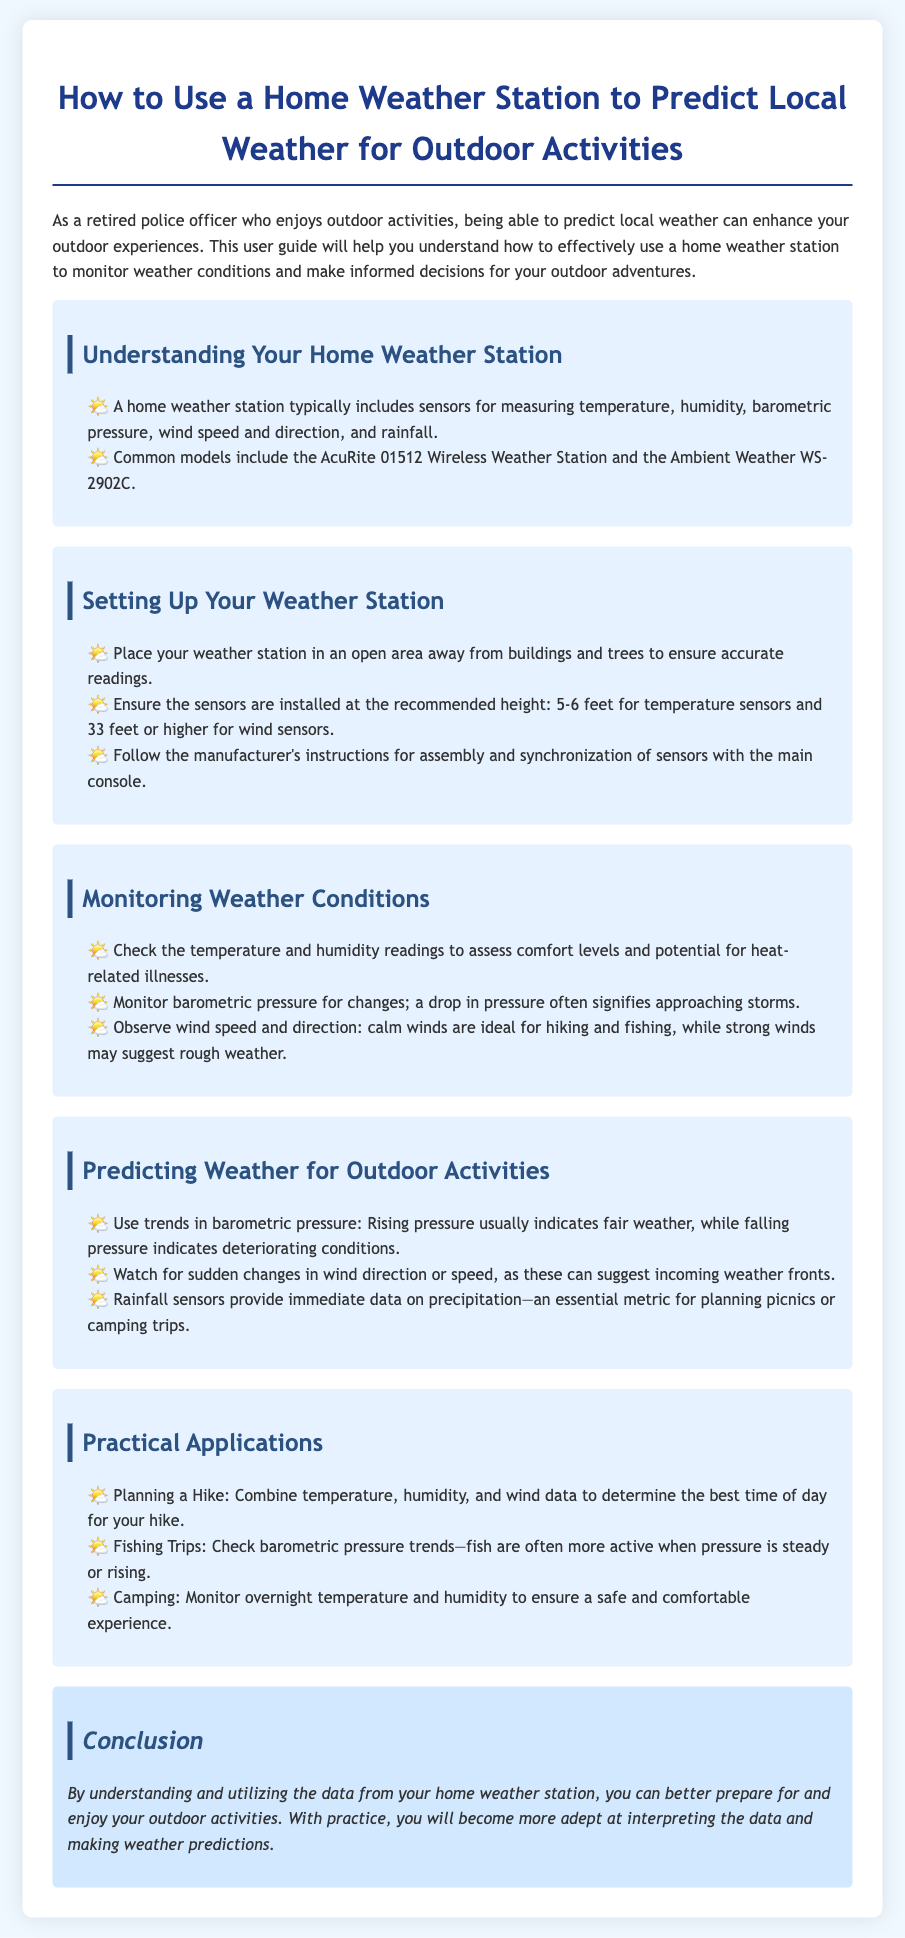what does a home weather station measure? A home weather station measures temperature, humidity, barometric pressure, wind speed and direction, and rainfall.
Answer: temperature, humidity, barometric pressure, wind speed, direction, rainfall what is the recommended height for temperature sensors? The document states the recommended height for temperature sensors is 5-6 feet.
Answer: 5-6 feet what can a drop in barometric pressure indicate? A drop in barometric pressure often signifies approaching storms.
Answer: approaching storms what is a practical use of monitoring wind data? Monitoring wind data helps determine ideal conditions for activities such as hiking and fishing.
Answer: hiking and fishing which weather station model is mentioned? The document mentions the AcuRite 01512 Wireless Weather Station as a common model.
Answer: AcuRite 01512 Wireless Weather Station how can rainfall sensors assist outdoor planning? Rainfall sensors provide immediate data on precipitation, which is essential for planning picnics or camping trips.
Answer: planning picnics or camping trips what trend in barometric pressure usually indicates fair weather? Rising pressure usually indicates fair weather.
Answer: Rising pressure what height should wind sensors be installed? Wind sensors should be installed at 33 feet or higher for accurate measurements.
Answer: 33 feet or higher how can understanding weather data enhance outdoor experiences? Understanding and utilizing data from your home weather station can help you better prepare for outdoor activities.
Answer: better prepare for outdoor activities 